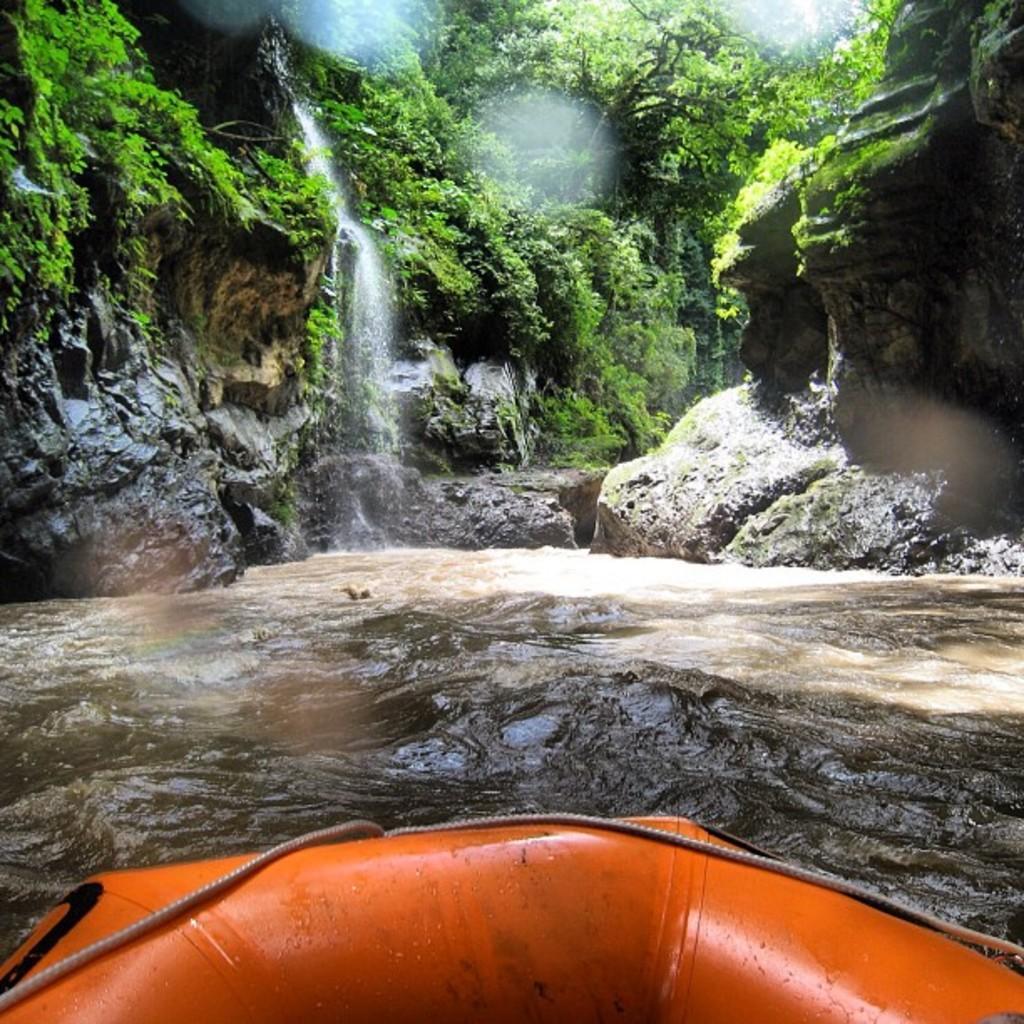How would you summarize this image in a sentence or two? In this image we can see waterfall, water, hills, trees and a boat. 